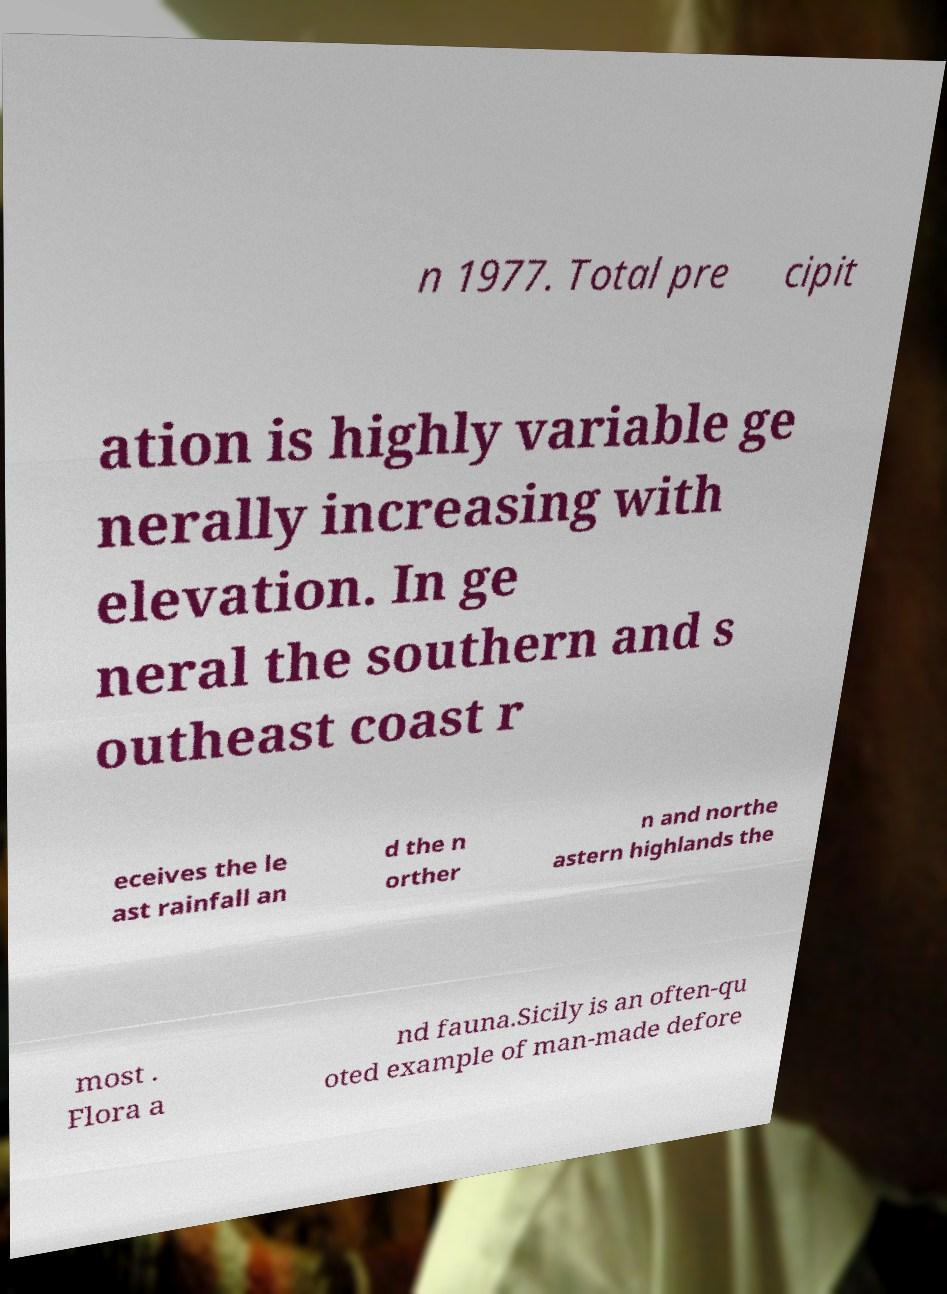Please identify and transcribe the text found in this image. n 1977. Total pre cipit ation is highly variable ge nerally increasing with elevation. In ge neral the southern and s outheast coast r eceives the le ast rainfall an d the n orther n and northe astern highlands the most . Flora a nd fauna.Sicily is an often-qu oted example of man-made defore 